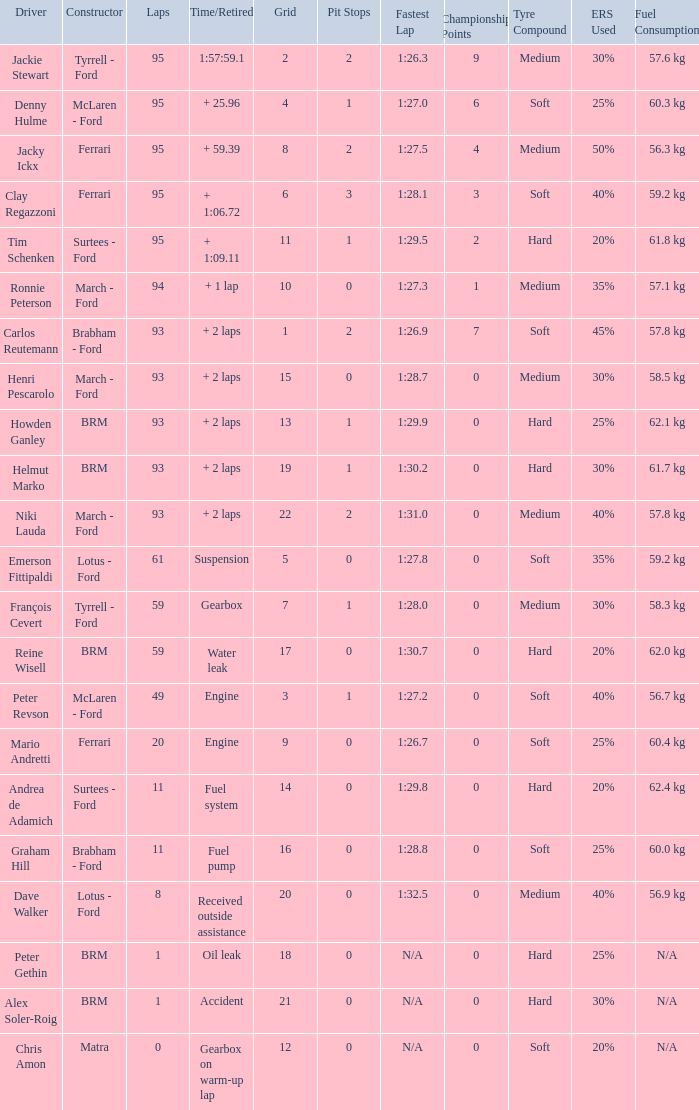What is the lowest grid with matra as constructor? 12.0. 